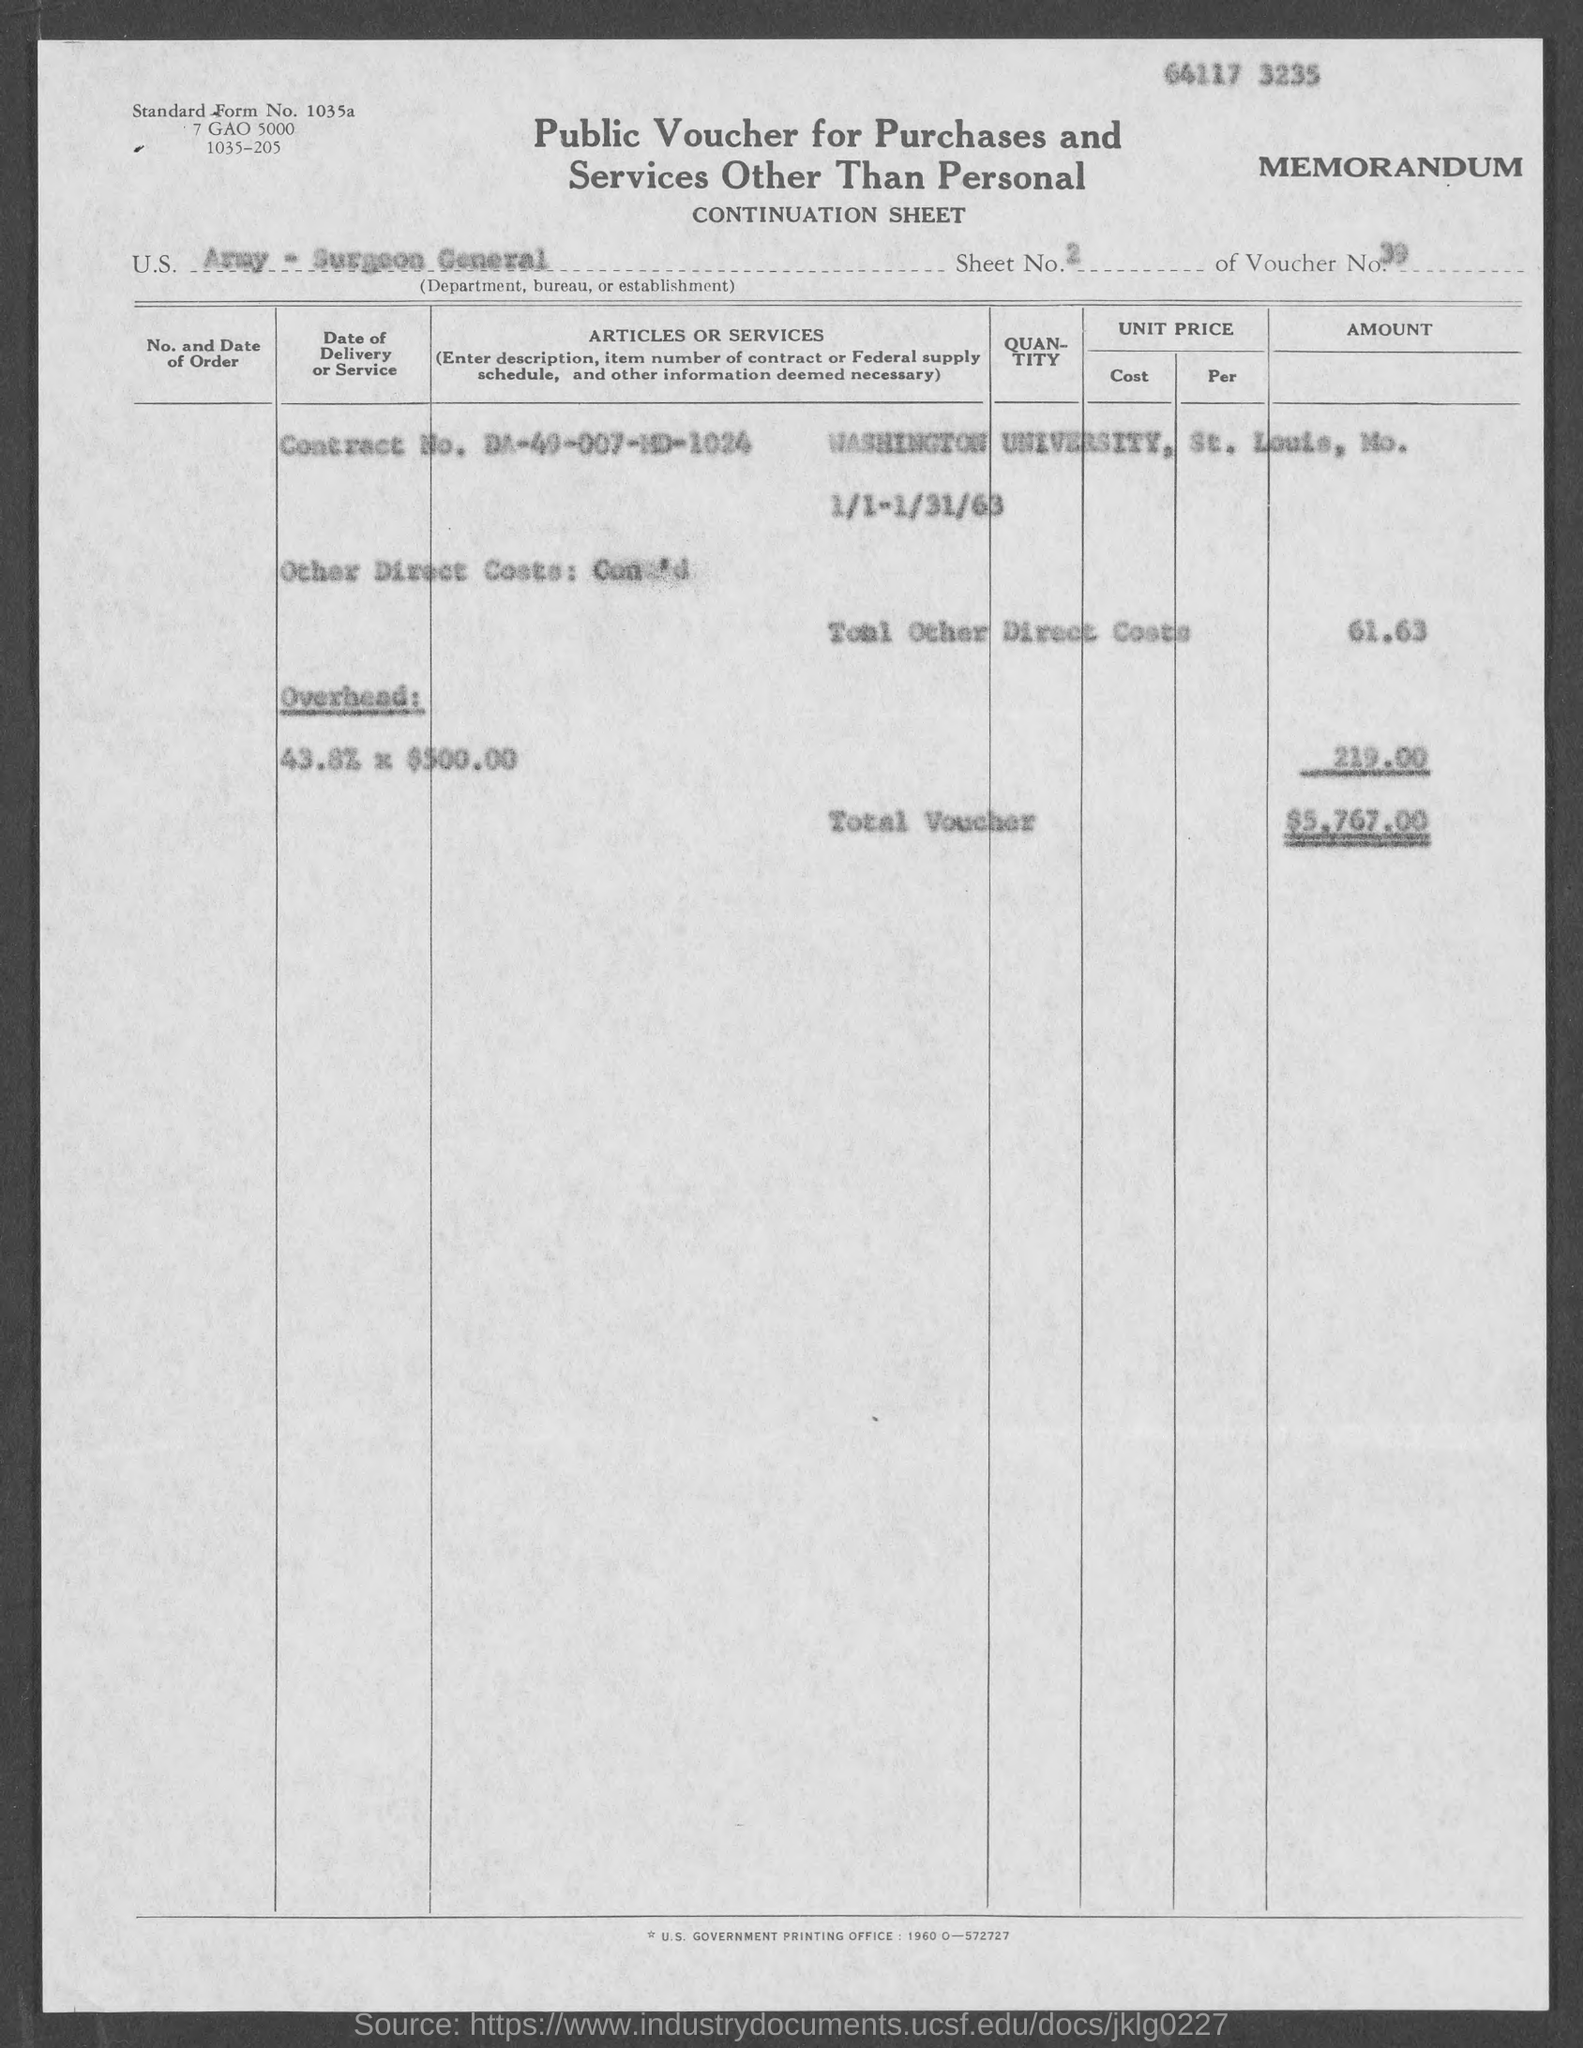What type of voucher is given here?
Give a very brief answer. Public Voucher for Purchases and Services other than Personal. What is the Standard Form No. given in the voucher?
Give a very brief answer. 1035a. What is the Sheet No. mentioned in the voucher?
Keep it short and to the point. 2. What is the U.S. Department, Bureau, or Establishment given in the voucher?
Make the answer very short. Army - Surgeon General. What is the voucher no given in the document?
Offer a terse response. 39. What is the Contract No. given in the voucher?
Provide a succinct answer. DA-49-007-MD-1024. What is the total voucher amount mentioned in the document?
Offer a terse response. $5,767.00. 